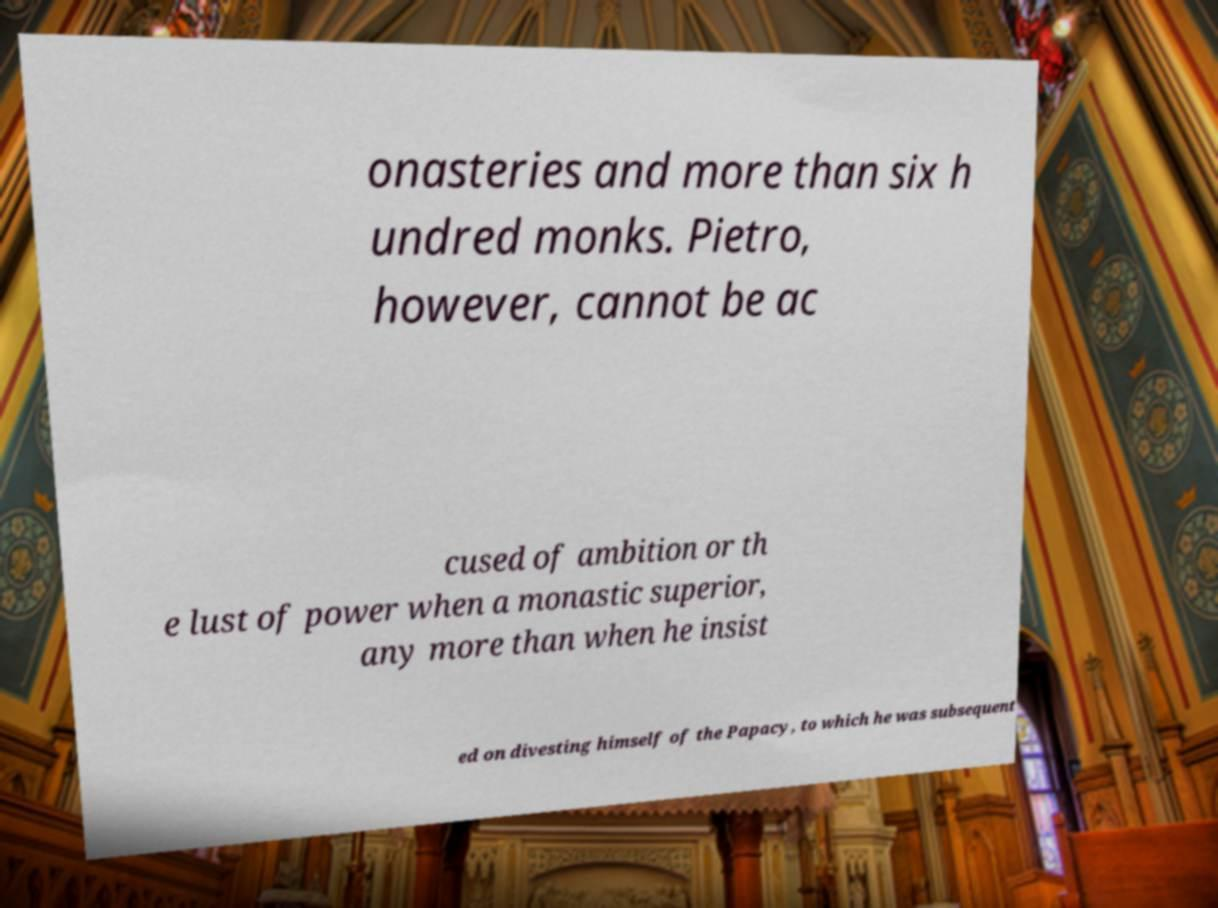I need the written content from this picture converted into text. Can you do that? onasteries and more than six h undred monks. Pietro, however, cannot be ac cused of ambition or th e lust of power when a monastic superior, any more than when he insist ed on divesting himself of the Papacy, to which he was subsequent 